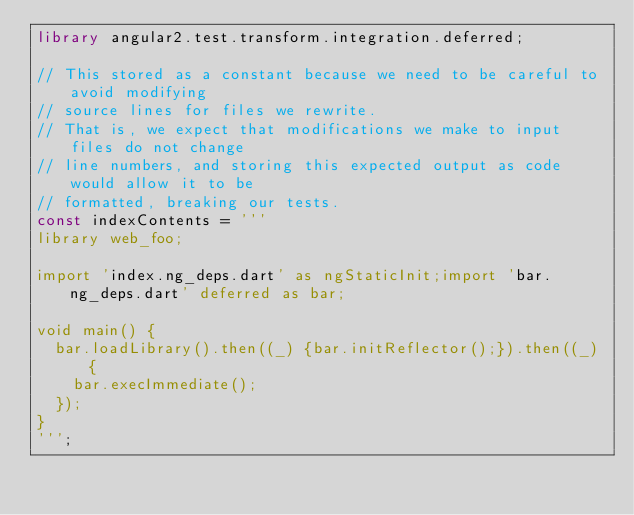Convert code to text. <code><loc_0><loc_0><loc_500><loc_500><_Dart_>library angular2.test.transform.integration.deferred;

// This stored as a constant because we need to be careful to avoid modifying
// source lines for files we rewrite.
// That is, we expect that modifications we make to input files do not change
// line numbers, and storing this expected output as code would allow it to be
// formatted, breaking our tests.
const indexContents = '''
library web_foo;

import 'index.ng_deps.dart' as ngStaticInit;import 'bar.ng_deps.dart' deferred as bar;

void main() {
  bar.loadLibrary().then((_) {bar.initReflector();}).then((_) {
    bar.execImmediate();
  });
}
''';
</code> 